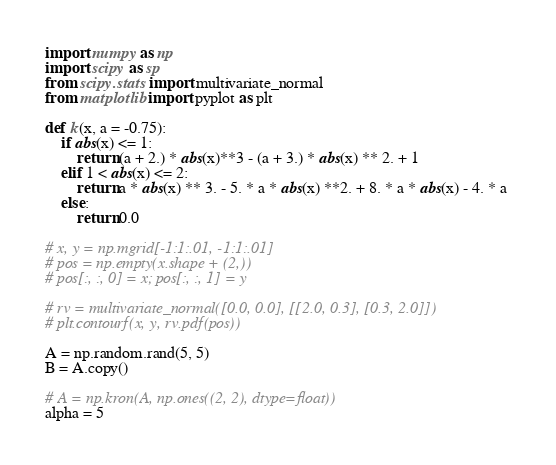<code> <loc_0><loc_0><loc_500><loc_500><_Python_>import numpy as np
import scipy as sp 
from scipy.stats import multivariate_normal
from matplotlib import pyplot as plt

def k(x, a = -0.75):
    if abs(x) <= 1:
        return (a + 2.) * abs(x)**3 - (a + 3.) * abs(x) ** 2. + 1
    elif 1 < abs(x) <= 2:
        return a * abs(x) ** 3. - 5. * a * abs(x) **2. + 8. * a * abs(x) - 4. * a 
    else:
        return 0.0
        
# x, y = np.mgrid[-1:1:.01, -1:1:.01]
# pos = np.empty(x.shape + (2,))
# pos[:, :, 0] = x; pos[:, :, 1] = y

# rv = multivariate_normal([0.0, 0.0], [[2.0, 0.3], [0.3, 2.0]])
# plt.contourf(x, y, rv.pdf(pos))

A = np.random.rand(5, 5)
B = A.copy()

# A = np.kron(A, np.ones((2, 2), dtype=float))
alpha = 5</code> 